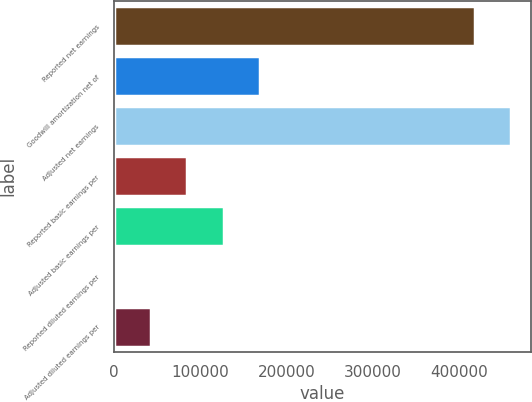Convert chart to OTSL. <chart><loc_0><loc_0><loc_500><loc_500><bar_chart><fcel>Reported net earnings<fcel>Goodwill amortization net of<fcel>Adjusted net earnings<fcel>Reported basic earnings per<fcel>Adjusted basic earnings per<fcel>Reported diluted earnings per<fcel>Adjusted diluted earnings per<nl><fcel>417845<fcel>169599<fcel>460244<fcel>84800.8<fcel>127200<fcel>2.73<fcel>42401.8<nl></chart> 